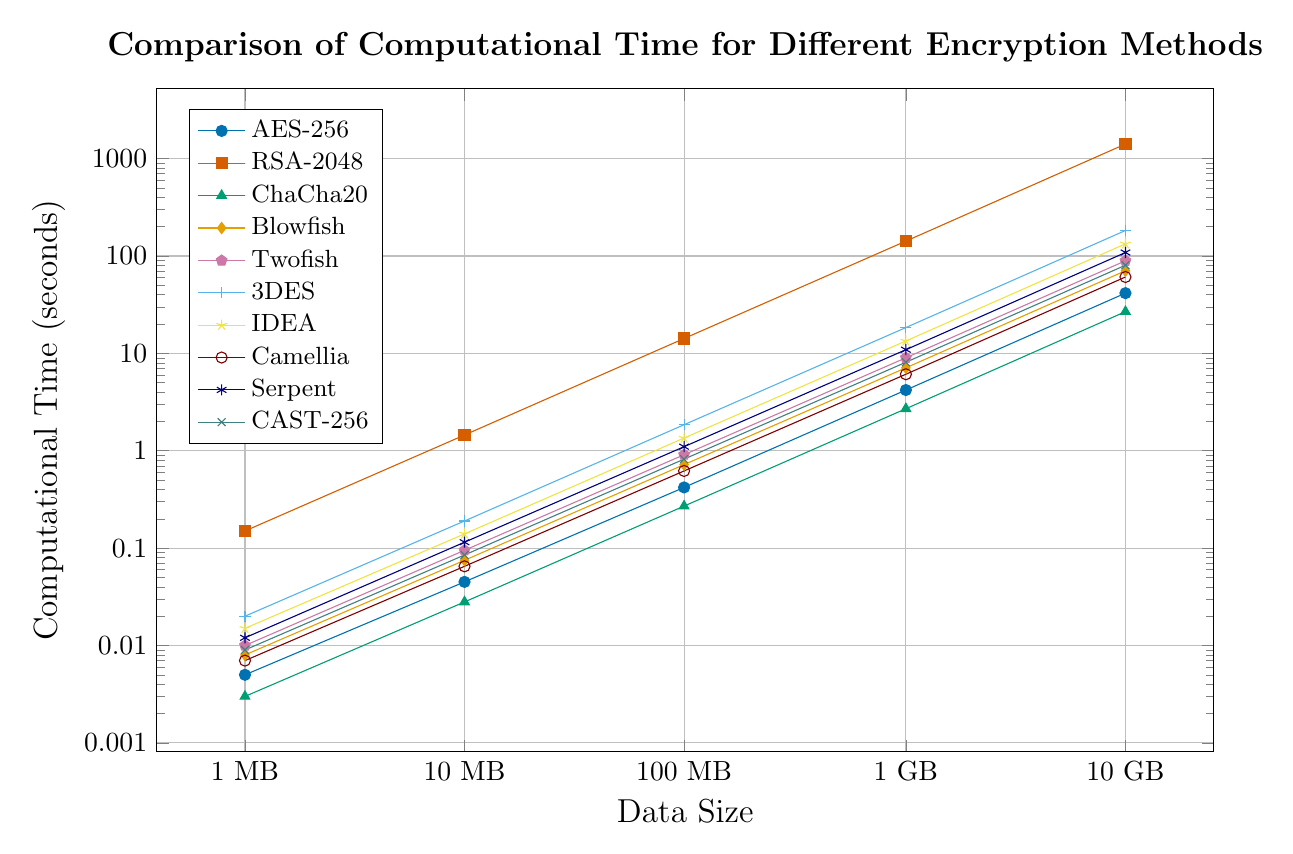Which encryption method has the lowest computational time for 1 MB of data? By examining the y-axis values for 1 MB data points, we can observe that ChaCha20 has the lowest computational time.
Answer: ChaCha20 What is the total computational time for AES-256, Blowfish, and Twofish for 10 MB of data? Look at the 10 MB data points for AES-256, Blowfish, and Twofish. Their computational times are 0.045, 0.075, and 0.095 seconds, respectively. Adding these values together: 0.045 + 0.075 + 0.095 = 0.215 seconds.
Answer: 0.215 seconds Compare the computational times for AES-256 and RSA-2048 at 10 MB. Which one is faster and by how much? The computational time for AES-256 at 10 MB is 0.045 seconds, and for RSA-2048 at 10 MB, it is 1.45 seconds. The difference is 1.45 - 0.045 = 1.405 seconds, with AES-256 being faster by 1.405 seconds.
Answer: AES-256 by 1.405 seconds How many times faster is ChaCha20 compared to 3DES for 1 GB of data? The computational time for ChaCha20 at 1 GB is 2.7 seconds and for 3DES it is 18.4 seconds. To find how many times faster ChaCha20 is, calculate 18.4 / 2.7 = 6.81. So, ChaCha20 is approximately 6.81 times faster.
Answer: 6.81 times Which method has a computational time between 50 and 60 seconds for 10 GB of data? Checking the y-axis values for 10 GB data points, it shows that Camellia has a computational time of 60.8 seconds, falling very close to the 50-60 range.
Answer: Camellia What is the average computational time for ChaCha20 across all data sizes? The computational times for ChaCha20 are 0.003, 0.028, 0.27, 2.7, and 26.8. Adding these together: 0.003 + 0.028 + 0.27 + 2.7 + 26.8 = 29.801. There are 5 data points, so the average is 29.801 / 5 = 5.9602 seconds.
Answer: 5.9602 seconds How does the computational time of Serpent compare to AES-256 for 100 MB data size? The computational time for Serpent at 100 MB is 1.1 seconds, and for AES-256 it is 0.42 seconds. Serpent is slower by 1.1 - 0.42 = 0.68 seconds.
Answer: Serpent is slower by 0.68 seconds Which encryption methods have computational times under 1 second for 100 MB of data? Observing the computational times for 100 MB data points, the methods under 1 second are: AES-256 (0.42), ChaCha20 (0.27), Blowfish (0.72), Camellia (0.62), CAST-256 (0.82).
Answer: AES-256, ChaCha20, Blowfish, Camellia, CAST-256 What is the computational time difference between the fastest and slowest methods for 10 GB of data? The fastest method for 10 GB is ChaCha20 with a time of 26.8 seconds, and the slowest method is RSA-2048 with 1410 seconds. The difference is 1410 - 26.8 = 1383.2 seconds.
Answer: 1383.2 seconds 